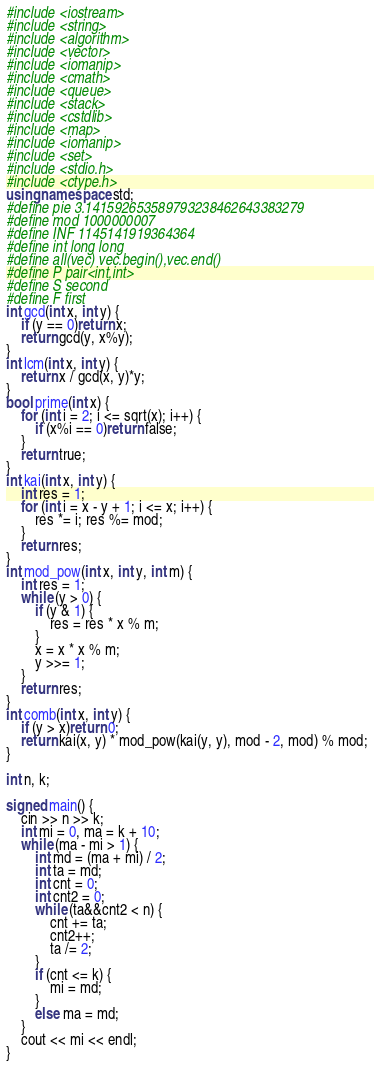Convert code to text. <code><loc_0><loc_0><loc_500><loc_500><_C++_>#include <iostream>
#include <string>
#include <algorithm>
#include <vector>
#include <iomanip>
#include <cmath>
#include <queue>
#include <stack>
#include <cstdlib>
#include <map>
#include <iomanip>
#include <set>
#include <stdio.h>
#include <ctype.h>
using namespace std;
#define pie 3.141592653589793238462643383279
#define mod 1000000007
#define INF 1145141919364364
#define int long long
#define all(vec) vec.begin(),vec.end()
#define P pair<int,int>
#define S second
#define F first
int gcd(int x, int y) {
	if (y == 0)return x;
	return gcd(y, x%y);
}
int lcm(int x, int y) {
	return x / gcd(x, y)*y;
}
bool prime(int x) {
	for (int i = 2; i <= sqrt(x); i++) {
		if (x%i == 0)return false;
	}
	return true;
}
int kai(int x, int y) {
	int res = 1;
	for (int i = x - y + 1; i <= x; i++) {
		res *= i; res %= mod;
	}
	return res;
}
int mod_pow(int x, int y, int m) {
	int res = 1;
	while (y > 0) {
		if (y & 1) {
			res = res * x % m;
		}
		x = x * x % m;
		y >>= 1;
	}
	return res;
}
int comb(int x, int y) {
	if (y > x)return 0;
	return kai(x, y) * mod_pow(kai(y, y), mod - 2, mod) % mod;
}

int n, k;

signed main() {
	cin >> n >> k;
	int mi = 0, ma = k + 10;
	while (ma - mi > 1) {
		int md = (ma + mi) / 2;
		int ta = md;
		int cnt = 0;
		int cnt2 = 0;
		while (ta&&cnt2 < n) {
			cnt += ta;
			cnt2++;
			ta /= 2;
		}
		if (cnt <= k) {
			mi = md;
		}
		else ma = md;
	}
	cout << mi << endl;
}
</code> 